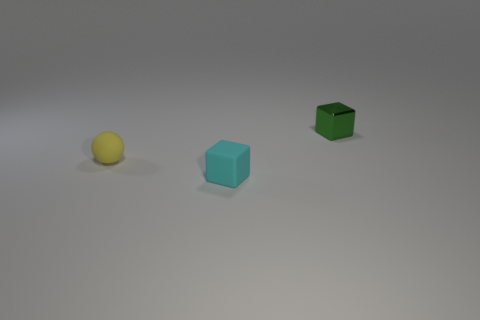Are there any green metal objects of the same size as the cyan matte object?
Provide a short and direct response. Yes. What number of other objects are there of the same material as the green block?
Provide a succinct answer. 0. What color is the tiny thing that is on the left side of the small green object and behind the cyan rubber block?
Your answer should be very brief. Yellow. Is the material of the cube on the left side of the metallic block the same as the cube that is right of the tiny cyan thing?
Ensure brevity in your answer.  No. Does the cube that is in front of the shiny cube have the same size as the yellow thing?
Keep it short and to the point. Yes. What is the shape of the cyan thing?
Your answer should be compact. Cube. How many objects are either tiny matte things that are behind the tiny cyan rubber thing or small yellow rubber objects?
Make the answer very short. 1. Are there more small matte things that are in front of the yellow rubber sphere than big gray metal cubes?
Offer a very short reply. Yes. Is the shape of the small cyan matte thing the same as the thing behind the sphere?
Your answer should be very brief. Yes. What number of large things are either brown rubber cylinders or matte cubes?
Your answer should be very brief. 0. 